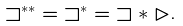Convert formula to latex. <formula><loc_0><loc_0><loc_500><loc_500>{ \sqsupset ^ { * * } } = { \sqsupset ^ { * } } = { \sqsupset * \vartriangleright } .</formula> 